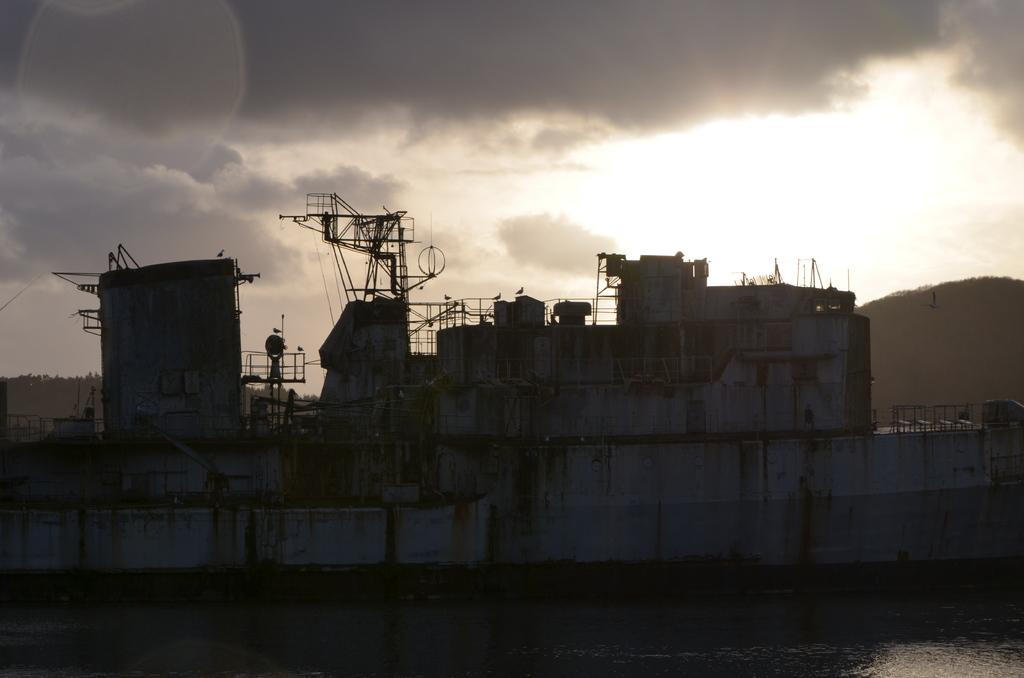What type of structure is present in the image? There is a factory in the image. How would you describe the weather based on the image? The sky is cloudy in the image. Can you identify any natural features in the image? There are hills visible in the image. What else can be seen in the image besides the factory and hills? There is water visible in the image, as well as unspecified objects. What type of flag is flying on top of the factory in the image? There is no flag visible on top of the factory in the image. Can you see a boot in the image? There is no boot present in the image. 